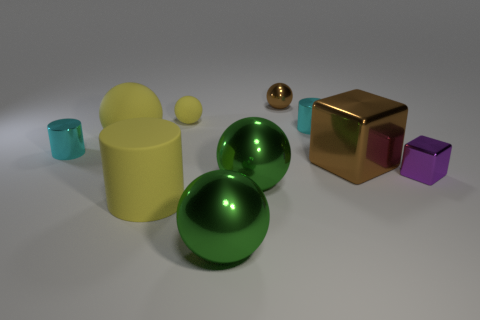Are there fewer tiny purple matte spheres than big brown metallic things?
Offer a very short reply. Yes. Do the tiny brown object and the rubber thing in front of the small purple block have the same shape?
Your response must be concise. No. What shape is the small object that is behind the small purple shiny block and right of the small metallic ball?
Give a very brief answer. Cylinder. Are there the same number of big metal cubes that are left of the yellow matte cylinder and big yellow matte spheres on the right side of the brown metal cube?
Your answer should be compact. Yes. Do the big yellow rubber object that is behind the matte cylinder and the big brown thing have the same shape?
Your answer should be compact. No. What number of yellow objects are metal things or big spheres?
Keep it short and to the point. 1. What material is the other large thing that is the same shape as the purple object?
Your answer should be very brief. Metal. What shape is the tiny cyan object to the right of the big yellow rubber cylinder?
Give a very brief answer. Cylinder. Are there any gray blocks made of the same material as the big yellow cylinder?
Offer a terse response. No. Is the size of the yellow matte cylinder the same as the purple thing?
Keep it short and to the point. No. 